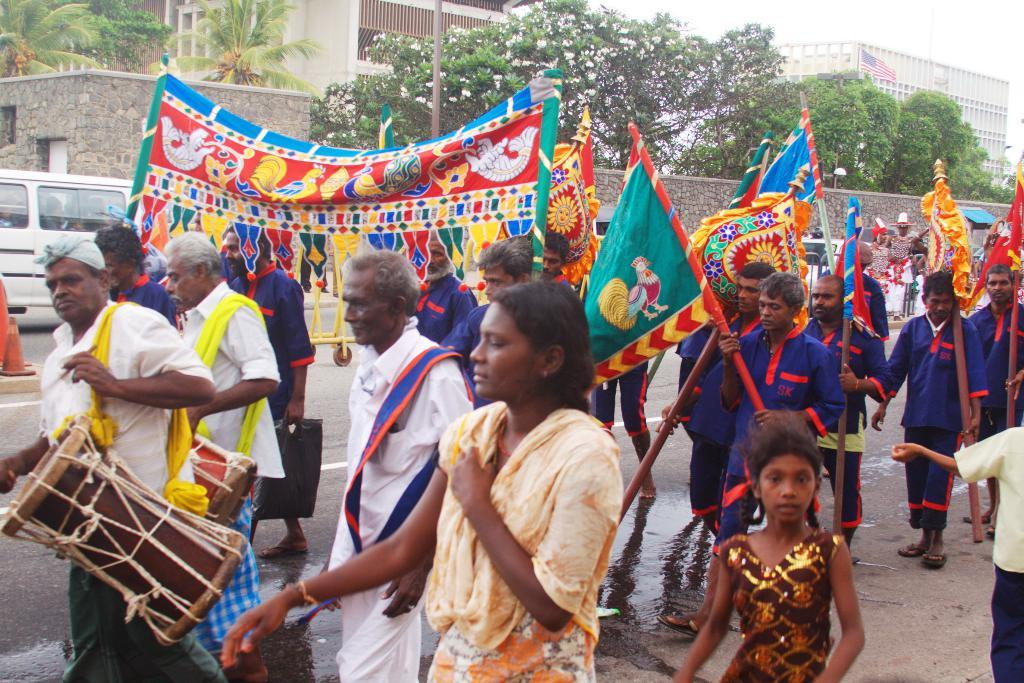What is happening in the image? There is a group of people in the image, and they are walking on a road. What can be seen in the background of the image? There are plants and buildings visible in the background, and the sky is clear. What type of test is being conducted by the people in the image? There is no test being conducted in the image; the people are simply walking on a road. What subject is being taught in the class that is visible in the image? There is no class visible in the image; it features a group of people walking on a road. 